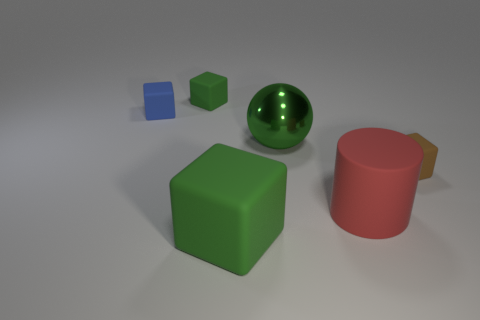What number of green metallic blocks have the same size as the green metal ball?
Give a very brief answer. 0. There is a large thing that is the same material as the big green block; what shape is it?
Keep it short and to the point. Cylinder. Are there any other matte cylinders of the same color as the cylinder?
Provide a succinct answer. No. What is the material of the big block?
Provide a short and direct response. Rubber. What number of objects are brown cubes or metallic blocks?
Your answer should be compact. 1. What size is the red object in front of the tiny green cube?
Offer a terse response. Large. What number of other objects are the same material as the sphere?
Make the answer very short. 0. Are there any green metal objects behind the tiny blue rubber thing that is on the left side of the small green cube?
Offer a terse response. No. Is there any other thing that is the same shape as the red matte object?
Offer a terse response. No. There is a big rubber object that is the same shape as the tiny blue object; what color is it?
Give a very brief answer. Green. 